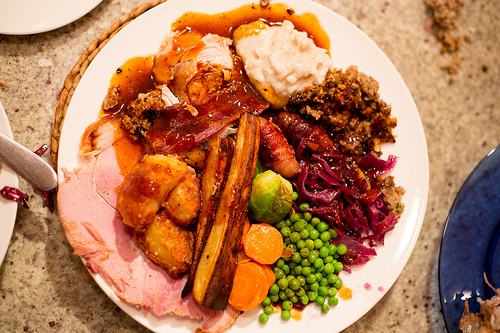<image>
Is the brussels sprout on the peas? Yes. Looking at the image, I can see the brussels sprout is positioned on top of the peas, with the peas providing support. Is there a food to the left of the plate? No. The food is not to the left of the plate. From this viewpoint, they have a different horizontal relationship. 